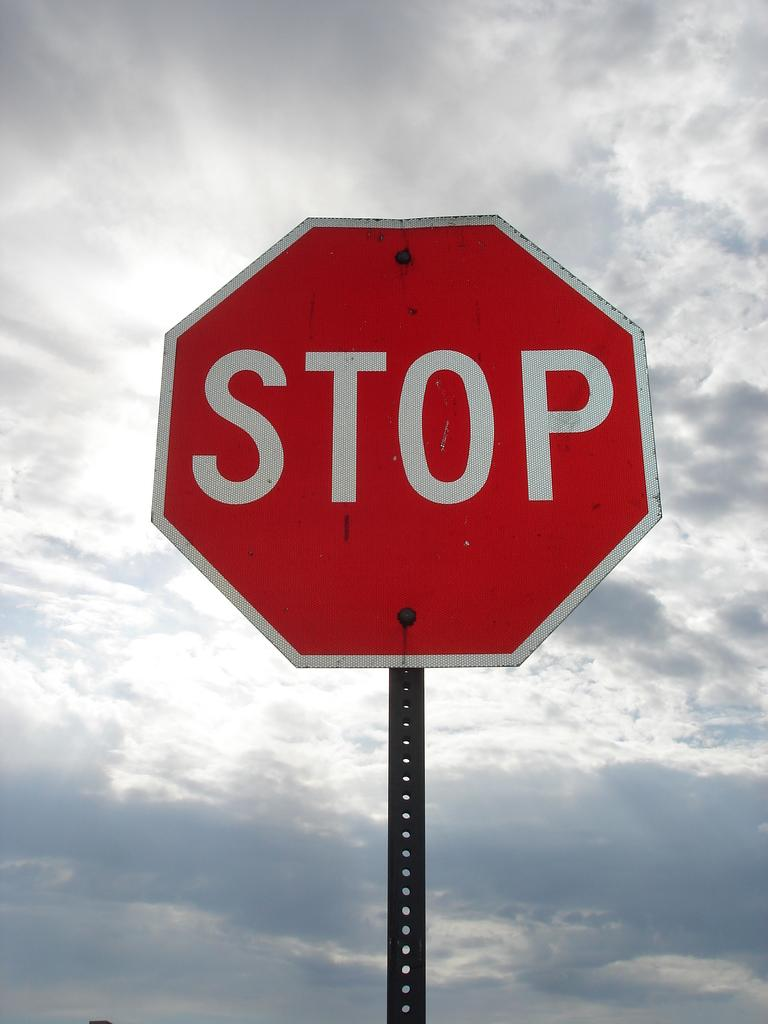<image>
Give a short and clear explanation of the subsequent image. a stop sign that is outside with clouds above 